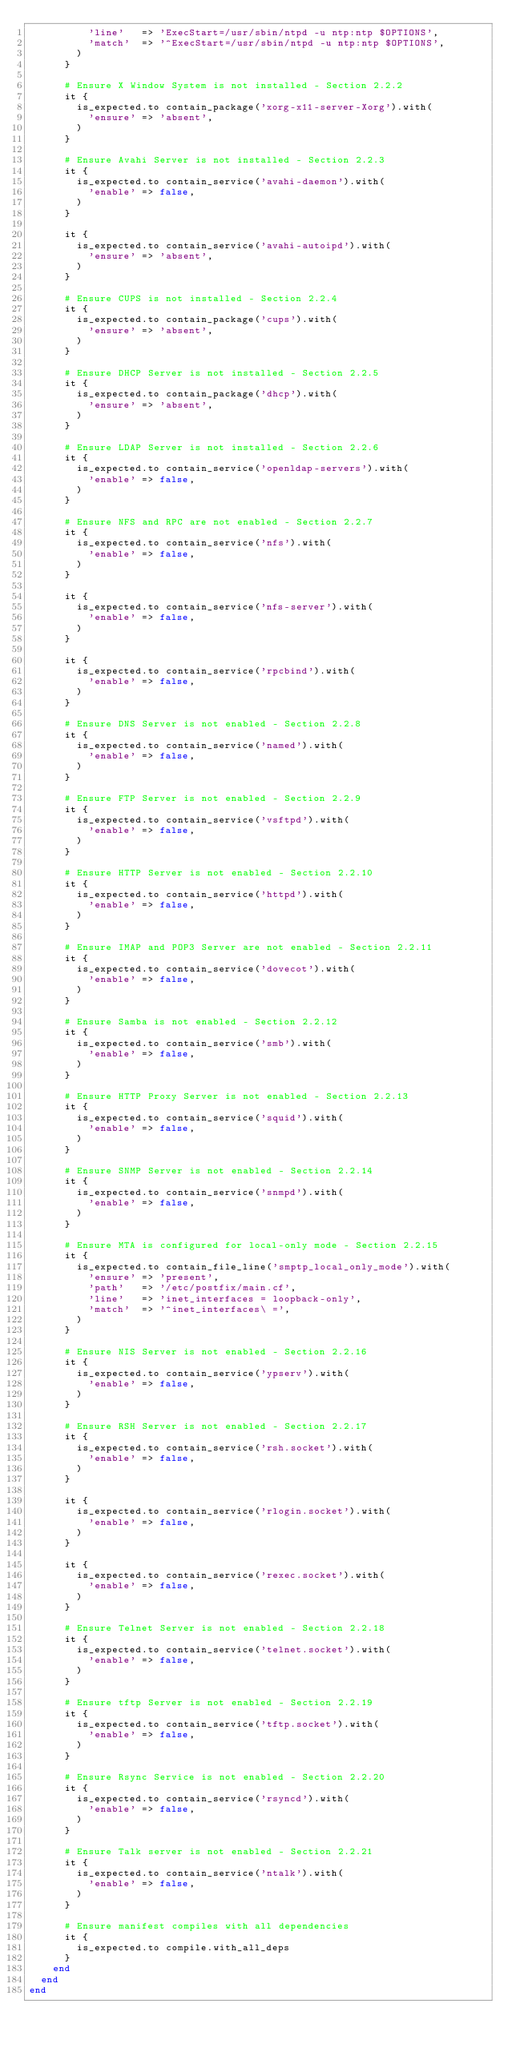Convert code to text. <code><loc_0><loc_0><loc_500><loc_500><_Ruby_>          'line'   => 'ExecStart=/usr/sbin/ntpd -u ntp:ntp $OPTIONS',
          'match'  => '^ExecStart=/usr/sbin/ntpd -u ntp:ntp $OPTIONS',
        )
      }
      
      # Ensure X Window System is not installed - Section 2.2.2
      it {
        is_expected.to contain_package('xorg-x11-server-Xorg').with(
          'ensure' => 'absent',
        )
      }

      # Ensure Avahi Server is not installed - Section 2.2.3
      it {
        is_expected.to contain_service('avahi-daemon').with(
          'enable' => false,
        )
      }

      it {
        is_expected.to contain_service('avahi-autoipd').with(
          'ensure' => 'absent',
        )
      }

      # Ensure CUPS is not installed - Section 2.2.4
      it {
        is_expected.to contain_package('cups').with(
          'ensure' => 'absent',
        )
      }

      # Ensure DHCP Server is not installed - Section 2.2.5
      it {
        is_expected.to contain_package('dhcp').with(
          'ensure' => 'absent',
        )
      }

      # Ensure LDAP Server is not installed - Section 2.2.6
      it {
        is_expected.to contain_service('openldap-servers').with(
          'enable' => false,
        )
      }

      # Ensure NFS and RPC are not enabled - Section 2.2.7
      it {
        is_expected.to contain_service('nfs').with(
          'enable' => false,
        )
      }

      it {
        is_expected.to contain_service('nfs-server').with(
          'enable' => false,
        )
      }

      it {
        is_expected.to contain_service('rpcbind').with(
          'enable' => false,
        )
      }

      # Ensure DNS Server is not enabled - Section 2.2.8
      it {
        is_expected.to contain_service('named').with(
          'enable' => false,
        )
      }

      # Ensure FTP Server is not enabled - Section 2.2.9
      it {
        is_expected.to contain_service('vsftpd').with(
          'enable' => false,
        )
      }

      # Ensure HTTP Server is not enabled - Section 2.2.10
      it {
        is_expected.to contain_service('httpd').with(
          'enable' => false,
        )
      }

      # Ensure IMAP and POP3 Server are not enabled - Section 2.2.11
      it {
        is_expected.to contain_service('dovecot').with(
          'enable' => false,
        )
      }

      # Ensure Samba is not enabled - Section 2.2.12
      it {
        is_expected.to contain_service('smb').with(
          'enable' => false,
        )
      }

      # Ensure HTTP Proxy Server is not enabled - Section 2.2.13
      it {
        is_expected.to contain_service('squid').with(
          'enable' => false,
        )
      }

      # Ensure SNMP Server is not enabled - Section 2.2.14
      it {
        is_expected.to contain_service('snmpd').with(
          'enable' => false,
        )
      }

      # Ensure MTA is configured for local-only mode - Section 2.2.15
      it {
        is_expected.to contain_file_line('smptp_local_only_mode').with(
          'ensure' => 'present',
          'path'   => '/etc/postfix/main.cf',
          'line'   => 'inet_interfaces = loopback-only',
          'match'  => '^inet_interfaces\ =',
        )
      }

      # Ensure NIS Server is not enabled - Section 2.2.16
      it {
        is_expected.to contain_service('ypserv').with(
          'enable' => false,
        )
      }

      # Ensure RSH Server is not enabled - Section 2.2.17
      it {
        is_expected.to contain_service('rsh.socket').with(
          'enable' => false,
        )
      }

      it {
        is_expected.to contain_service('rlogin.socket').with(
          'enable' => false,
        )
      }

      it {
        is_expected.to contain_service('rexec.socket').with(
          'enable' => false,
        )
      }

      # Ensure Telnet Server is not enabled - Section 2.2.18
      it {
        is_expected.to contain_service('telnet.socket').with(
          'enable' => false,
        )
      }

      # Ensure tftp Server is not enabled - Section 2.2.19
      it {
        is_expected.to contain_service('tftp.socket').with(
          'enable' => false,
        )
      }

      # Ensure Rsync Service is not enabled - Section 2.2.20
      it {
        is_expected.to contain_service('rsyncd').with(
          'enable' => false,
        )
      }

      # Ensure Talk server is not enabled - Section 2.2.21
      it {
        is_expected.to contain_service('ntalk').with(
          'enable' => false,
        )
      }

      # Ensure manifest compiles with all dependencies
      it {
        is_expected.to compile.with_all_deps
      }
    end
  end
end
</code> 